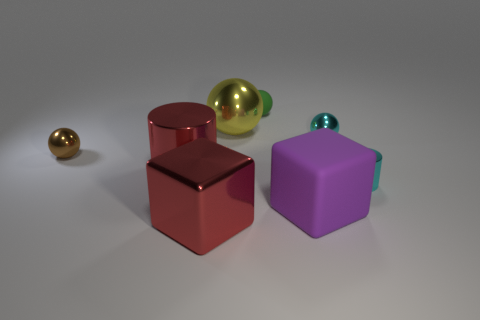Subtract all small brown balls. How many balls are left? 3 Subtract all green balls. How many balls are left? 3 Add 1 large red metal cylinders. How many objects exist? 9 Subtract all cylinders. How many objects are left? 6 Subtract all cyan balls. Subtract all green cubes. How many balls are left? 3 Subtract 1 red blocks. How many objects are left? 7 Subtract all tiny brown spheres. Subtract all small cyan shiny balls. How many objects are left? 6 Add 2 yellow metal spheres. How many yellow metal spheres are left? 3 Add 5 metal cylinders. How many metal cylinders exist? 7 